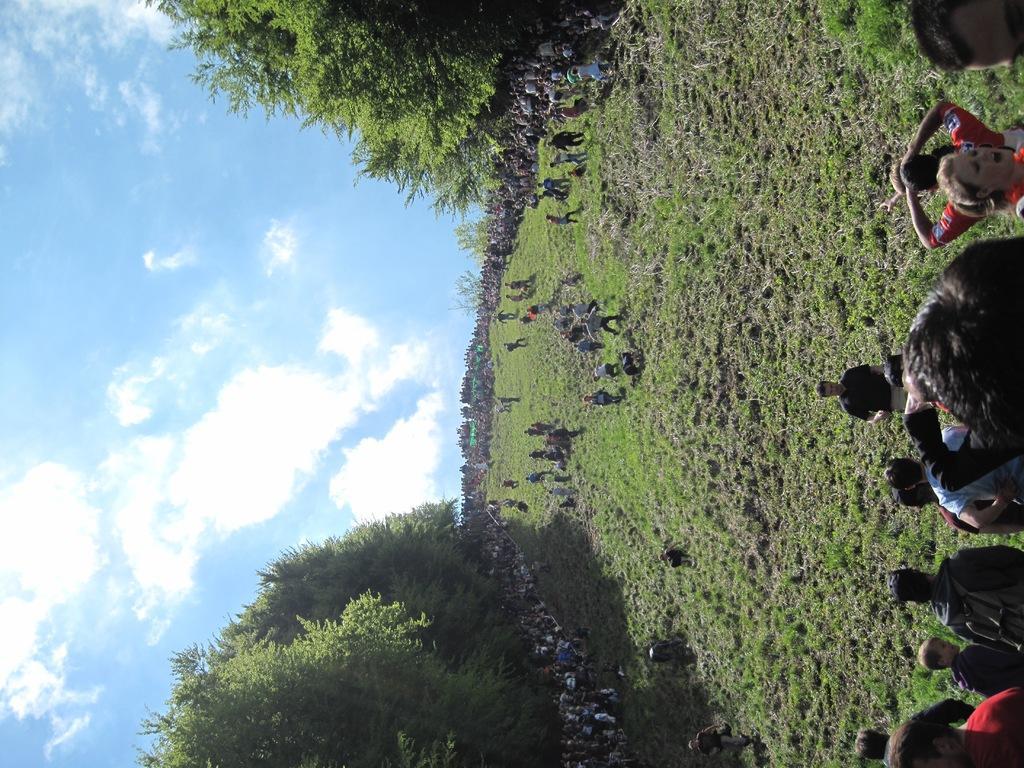How would you summarize this image in a sentence or two? In this image I can see few trees which are green in color, some grass on the ground and few persons are standing on the ground. In the background I can see number of persons are standing and the sky. 